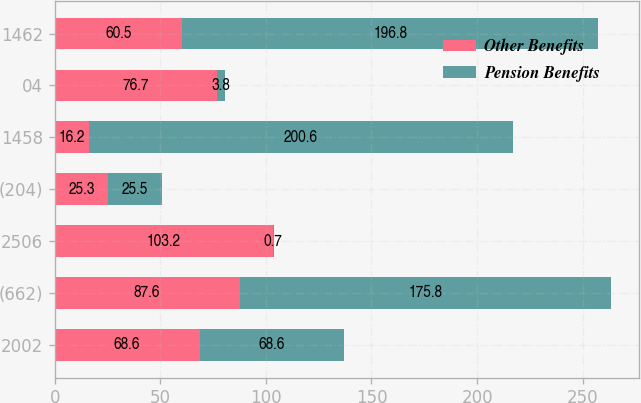<chart> <loc_0><loc_0><loc_500><loc_500><stacked_bar_chart><ecel><fcel>2002<fcel>(662)<fcel>2506<fcel>(204)<fcel>1458<fcel>04<fcel>1462<nl><fcel>Other Benefits<fcel>68.6<fcel>87.6<fcel>103.2<fcel>25.3<fcel>16.2<fcel>76.7<fcel>60.5<nl><fcel>Pension Benefits<fcel>68.6<fcel>175.8<fcel>0.7<fcel>25.5<fcel>200.6<fcel>3.8<fcel>196.8<nl></chart> 